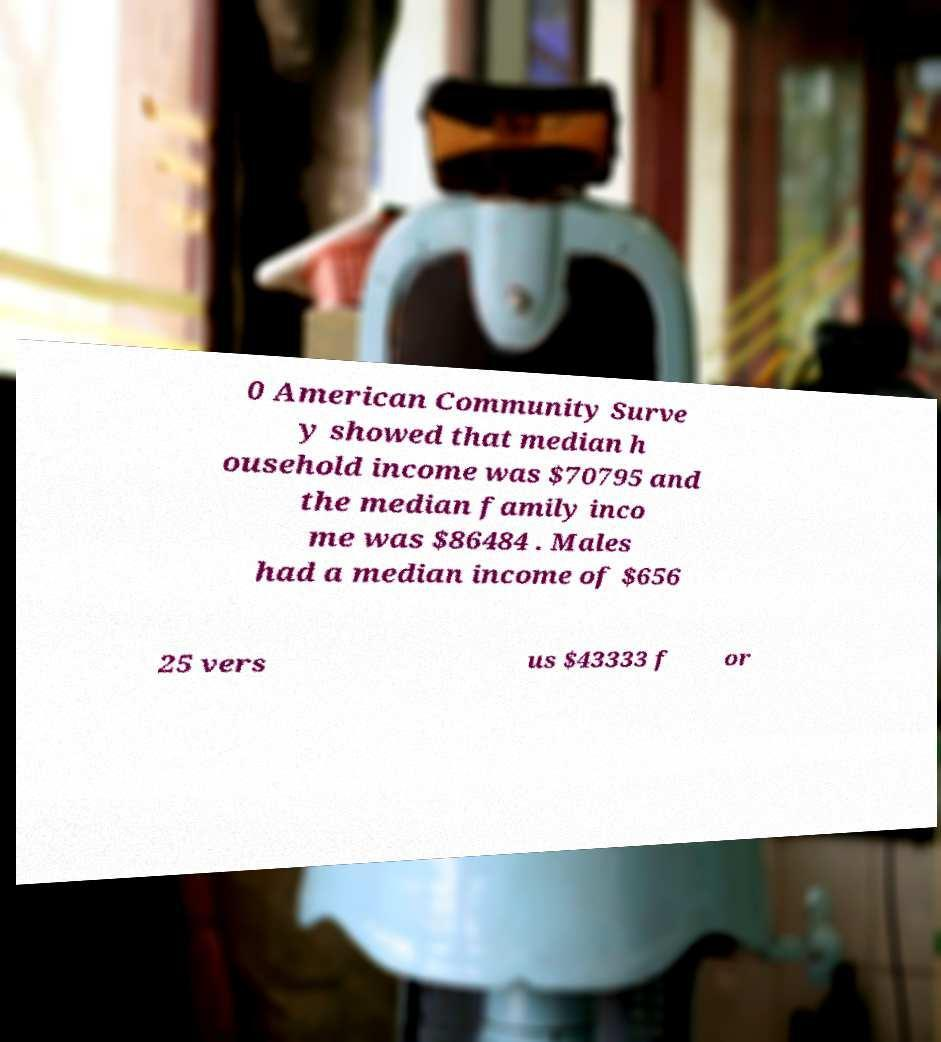Could you extract and type out the text from this image? 0 American Community Surve y showed that median h ousehold income was $70795 and the median family inco me was $86484 . Males had a median income of $656 25 vers us $43333 f or 